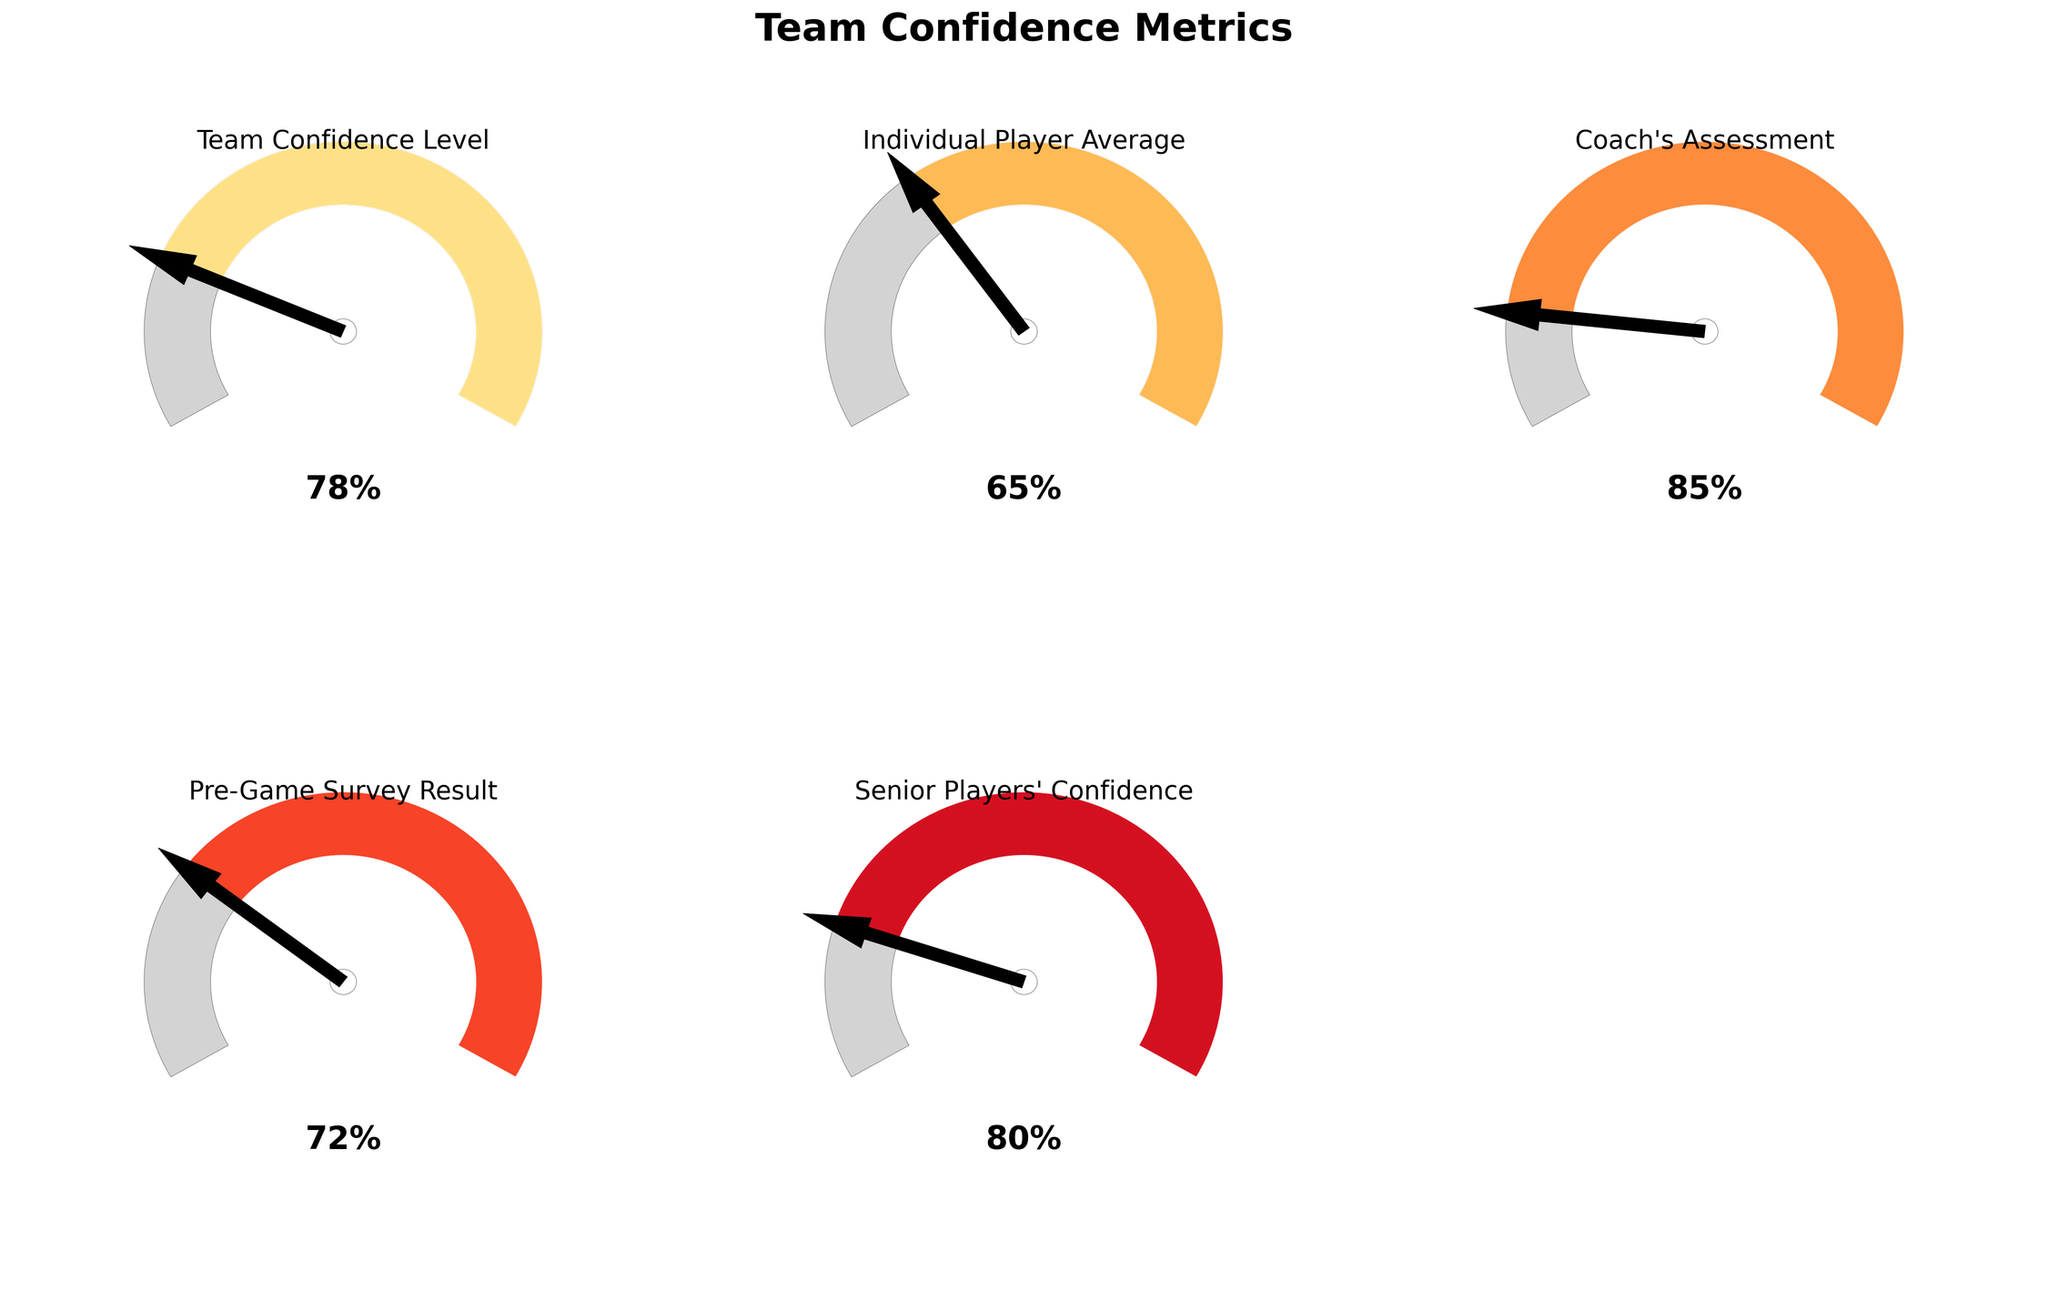What is the title of the figure? The title is usually displayed prominently at the top of the figure. It helps to understand the main theme or focus of the displayed data.
Answer: Team Confidence Metrics How many gauges are present in the figure? By observing the figure, count the number of separate gauge charts present.
Answer: 5 Which label corresponds to the highest confidence level? Look at each gauge and identify the one with the highest percentage value.
Answer: Coach's Assessment What is the difference in confidence level between the Senior Players and Individual Player Average? Subtract the value of Individual Player Average from the value of Senior Players' Confidence.
Answer: 15 Which metric has the lowest confidence level? Compare the confidence levels displayed on each gauge to determine which is the lowest.
Answer: Individual Player Average Is the Pre-Game Survey Result above or below the Team Confidence Level? Look at the values of both Pre-Game Survey Result and Team Confidence Level and compare them.
Answer: Below What is the average confidence level of all measured metrics? Add up all the confidence levels and divide by the number of metrics to find the average. (78 + 65 + 85 + 72 + 80) / 5
Answer: 76 Which confidence level is closest to the overall Team Confidence Level? Compare each confidence level to the Team Confidence Level and identify the closest one.
Answer: Pre-Game Survey Result How much higher is the Coach's Assessment compared to the Individual Player Average? Subtract the value of Individual Player Average from the value of Coach's Assessment.
Answer: 20 Are there any confidence levels above 80? Check all the confidence level values to see if any are greater than 80.
Answer: Yes 